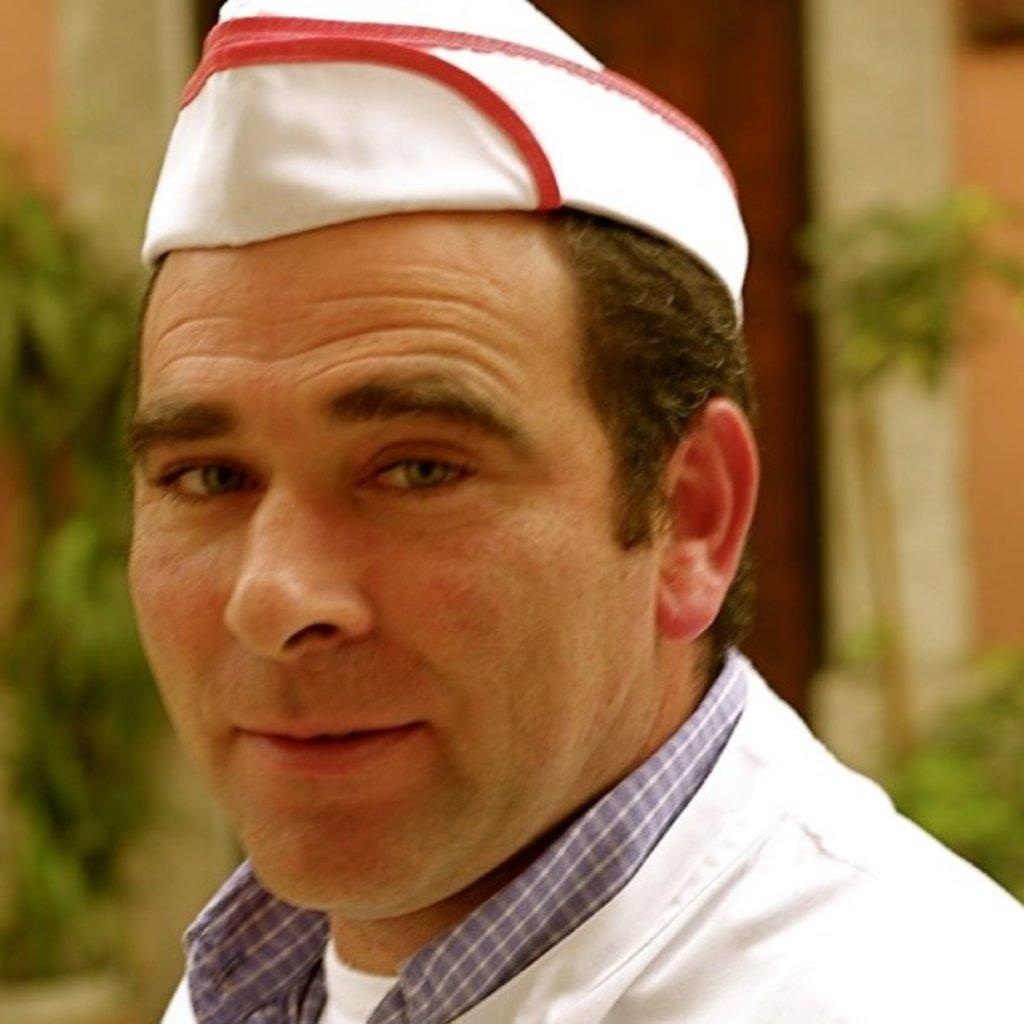Who or what is in the front of the image? There is a person in the front of the image. What can be seen in the background of the image? There are plants and a wall in the background of the image. Are there any architectural features visible in the background? Yes, there is a door in the background of the image. What type of joke is the person telling in the image? There is no indication in the image that the person is telling a joke, so it cannot be determined from the picture. 